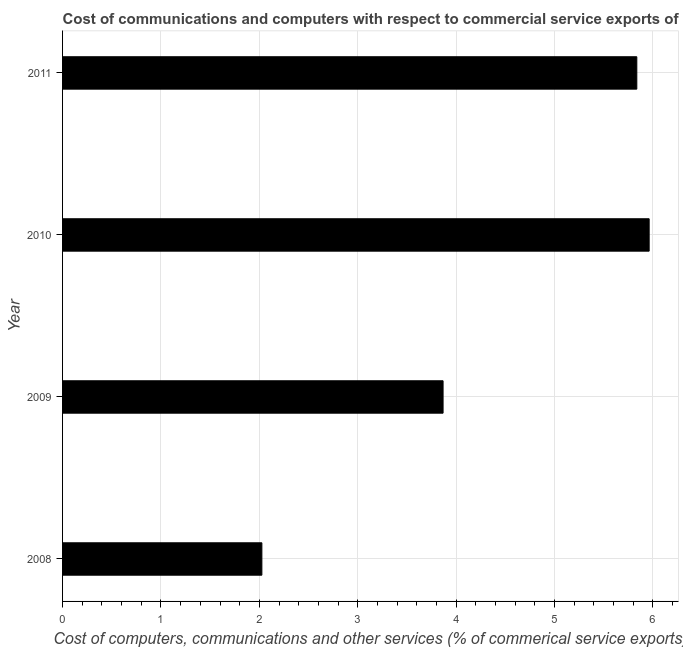What is the title of the graph?
Provide a succinct answer. Cost of communications and computers with respect to commercial service exports of Iraq. What is the label or title of the X-axis?
Keep it short and to the point. Cost of computers, communications and other services (% of commerical service exports). What is the  computer and other services in 2009?
Provide a succinct answer. 3.87. Across all years, what is the maximum  computer and other services?
Provide a succinct answer. 5.96. Across all years, what is the minimum cost of communications?
Offer a terse response. 2.03. In which year was the  computer and other services maximum?
Your answer should be compact. 2010. What is the sum of the cost of communications?
Offer a very short reply. 17.69. What is the difference between the cost of communications in 2009 and 2011?
Provide a succinct answer. -1.97. What is the average cost of communications per year?
Ensure brevity in your answer.  4.42. What is the median  computer and other services?
Keep it short and to the point. 4.85. What is the ratio of the cost of communications in 2008 to that in 2010?
Provide a short and direct response. 0.34. Is the cost of communications in 2009 less than that in 2011?
Your response must be concise. Yes. Is the difference between the  computer and other services in 2009 and 2011 greater than the difference between any two years?
Provide a short and direct response. No. What is the difference between the highest and the lowest cost of communications?
Make the answer very short. 3.94. Are all the bars in the graph horizontal?
Offer a terse response. Yes. What is the difference between two consecutive major ticks on the X-axis?
Offer a very short reply. 1. What is the Cost of computers, communications and other services (% of commerical service exports) of 2008?
Provide a short and direct response. 2.03. What is the Cost of computers, communications and other services (% of commerical service exports) in 2009?
Offer a very short reply. 3.87. What is the Cost of computers, communications and other services (% of commerical service exports) in 2010?
Your answer should be compact. 5.96. What is the Cost of computers, communications and other services (% of commerical service exports) of 2011?
Make the answer very short. 5.84. What is the difference between the Cost of computers, communications and other services (% of commerical service exports) in 2008 and 2009?
Make the answer very short. -1.84. What is the difference between the Cost of computers, communications and other services (% of commerical service exports) in 2008 and 2010?
Your answer should be compact. -3.94. What is the difference between the Cost of computers, communications and other services (% of commerical service exports) in 2008 and 2011?
Give a very brief answer. -3.81. What is the difference between the Cost of computers, communications and other services (% of commerical service exports) in 2009 and 2010?
Your answer should be very brief. -2.09. What is the difference between the Cost of computers, communications and other services (% of commerical service exports) in 2009 and 2011?
Offer a very short reply. -1.97. What is the difference between the Cost of computers, communications and other services (% of commerical service exports) in 2010 and 2011?
Provide a succinct answer. 0.13. What is the ratio of the Cost of computers, communications and other services (% of commerical service exports) in 2008 to that in 2009?
Your response must be concise. 0.52. What is the ratio of the Cost of computers, communications and other services (% of commerical service exports) in 2008 to that in 2010?
Keep it short and to the point. 0.34. What is the ratio of the Cost of computers, communications and other services (% of commerical service exports) in 2008 to that in 2011?
Provide a short and direct response. 0.35. What is the ratio of the Cost of computers, communications and other services (% of commerical service exports) in 2009 to that in 2010?
Your answer should be compact. 0.65. What is the ratio of the Cost of computers, communications and other services (% of commerical service exports) in 2009 to that in 2011?
Offer a very short reply. 0.66. What is the ratio of the Cost of computers, communications and other services (% of commerical service exports) in 2010 to that in 2011?
Offer a very short reply. 1.02. 